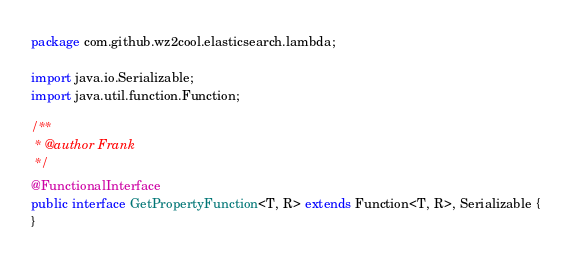<code> <loc_0><loc_0><loc_500><loc_500><_Java_>package com.github.wz2cool.elasticsearch.lambda;

import java.io.Serializable;
import java.util.function.Function;

/**
 * @author Frank
 */
@FunctionalInterface
public interface GetPropertyFunction<T, R> extends Function<T, R>, Serializable {
}</code> 